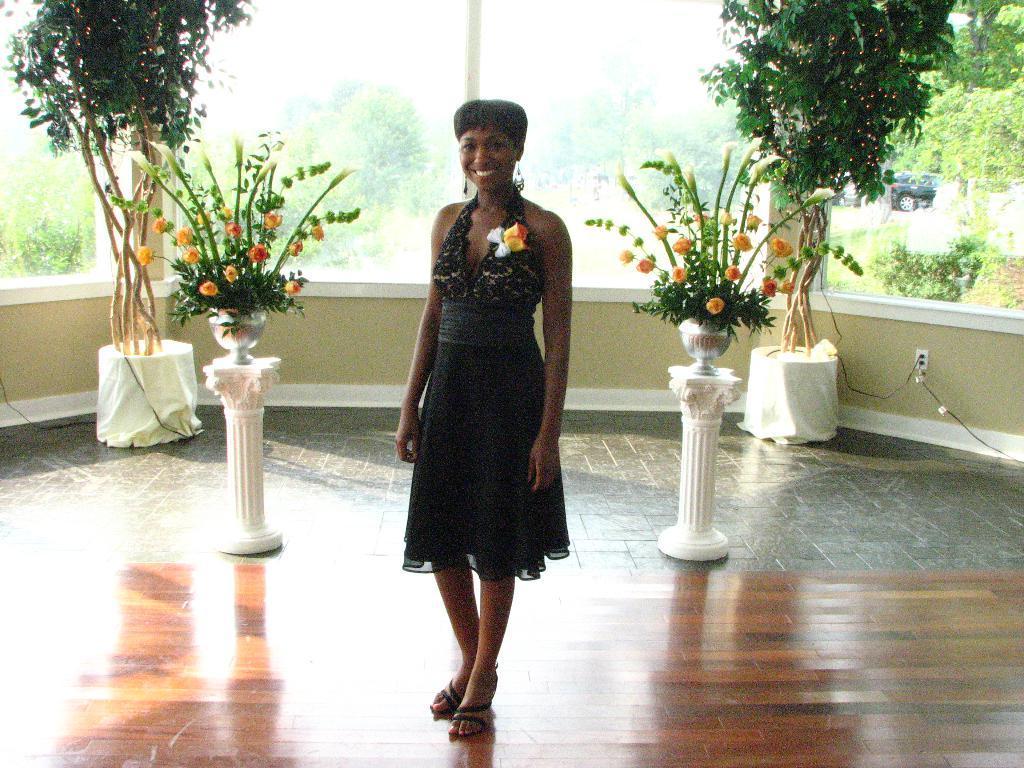Describe this image in one or two sentences. In this image we can see a woman standing on the floor. We can also see the flower pots on the poles, some plants in the pots, a wall and some wires. On the backside we can see a pole, some plants, trees and a vehicle on the ground. 